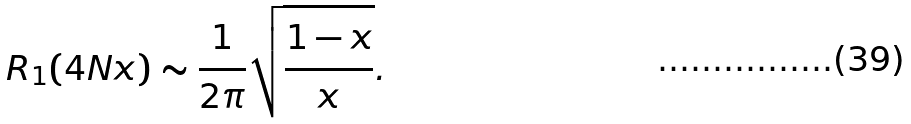Convert formula to latex. <formula><loc_0><loc_0><loc_500><loc_500>R _ { 1 } ( 4 N x ) \sim \frac { 1 } { 2 \pi } \sqrt { \frac { 1 - x } { x } } .</formula> 